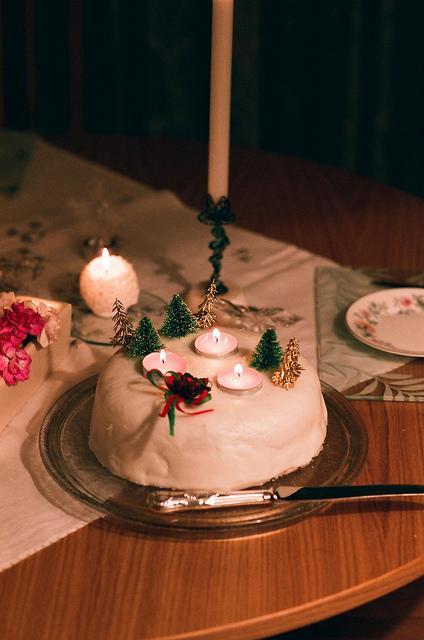Are the candles lit?
Keep it brief. Yes. What kind of cake?
Answer briefly. Christmas. What ICING IS USED ON THIS CAKE?
Answer briefly. Fondant. 